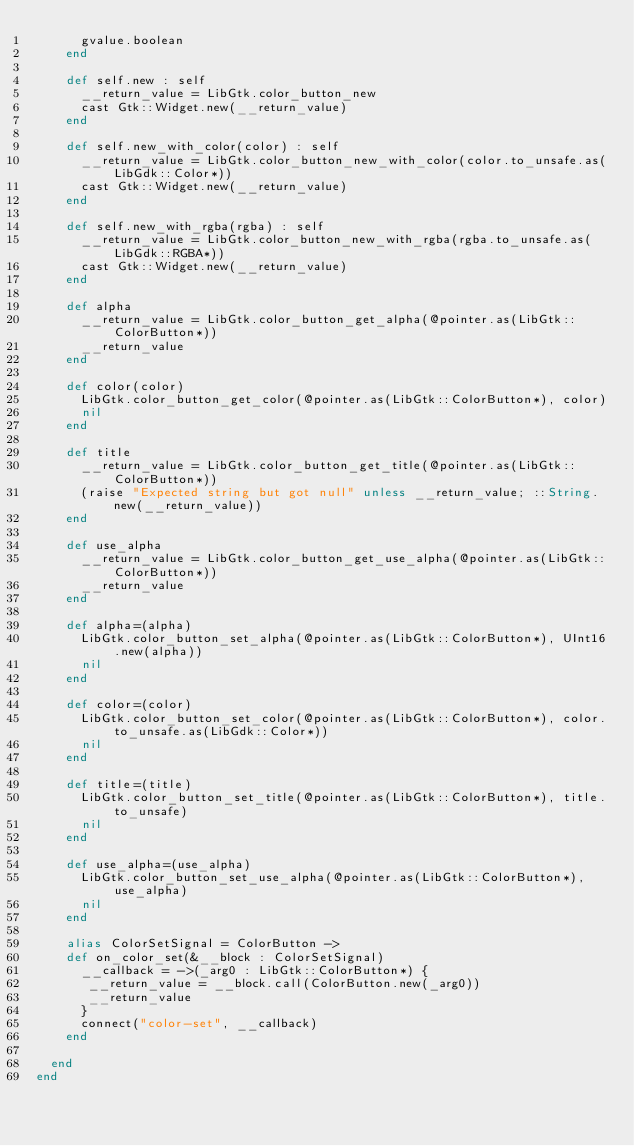<code> <loc_0><loc_0><loc_500><loc_500><_Crystal_>      gvalue.boolean
    end

    def self.new : self
      __return_value = LibGtk.color_button_new
      cast Gtk::Widget.new(__return_value)
    end

    def self.new_with_color(color) : self
      __return_value = LibGtk.color_button_new_with_color(color.to_unsafe.as(LibGdk::Color*))
      cast Gtk::Widget.new(__return_value)
    end

    def self.new_with_rgba(rgba) : self
      __return_value = LibGtk.color_button_new_with_rgba(rgba.to_unsafe.as(LibGdk::RGBA*))
      cast Gtk::Widget.new(__return_value)
    end

    def alpha
      __return_value = LibGtk.color_button_get_alpha(@pointer.as(LibGtk::ColorButton*))
      __return_value
    end

    def color(color)
      LibGtk.color_button_get_color(@pointer.as(LibGtk::ColorButton*), color)
      nil
    end

    def title
      __return_value = LibGtk.color_button_get_title(@pointer.as(LibGtk::ColorButton*))
      (raise "Expected string but got null" unless __return_value; ::String.new(__return_value))
    end

    def use_alpha
      __return_value = LibGtk.color_button_get_use_alpha(@pointer.as(LibGtk::ColorButton*))
      __return_value
    end

    def alpha=(alpha)
      LibGtk.color_button_set_alpha(@pointer.as(LibGtk::ColorButton*), UInt16.new(alpha))
      nil
    end

    def color=(color)
      LibGtk.color_button_set_color(@pointer.as(LibGtk::ColorButton*), color.to_unsafe.as(LibGdk::Color*))
      nil
    end

    def title=(title)
      LibGtk.color_button_set_title(@pointer.as(LibGtk::ColorButton*), title.to_unsafe)
      nil
    end

    def use_alpha=(use_alpha)
      LibGtk.color_button_set_use_alpha(@pointer.as(LibGtk::ColorButton*), use_alpha)
      nil
    end

    alias ColorSetSignal = ColorButton ->
    def on_color_set(&__block : ColorSetSignal)
      __callback = ->(_arg0 : LibGtk::ColorButton*) {
       __return_value = __block.call(ColorButton.new(_arg0))
       __return_value
      }
      connect("color-set", __callback)
    end

  end
end

</code> 